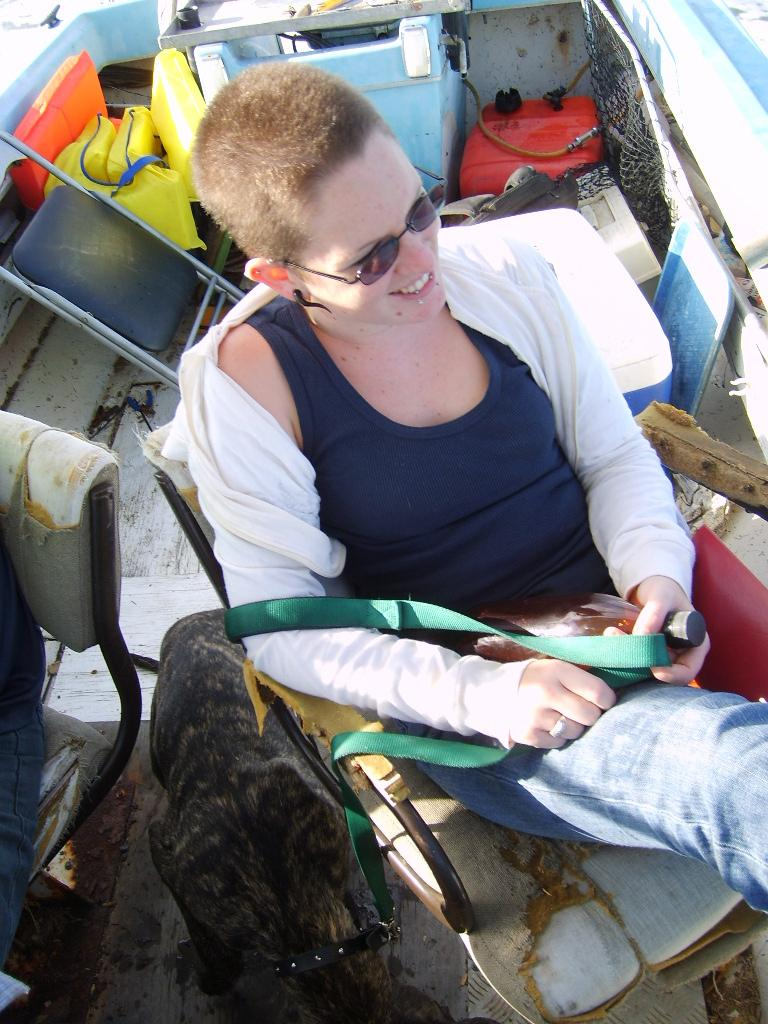Who is the main subject in the image? There is a lady in the image. What is the lady wearing on her face? The lady is wearing goggles. What object is the lady holding? The lady is holding a belt. What can be seen sitting on a chair in the image? There is a bottle sitting on a chair. What type of animal is near the lady? There is an animal near the lady. What can be seen in the background of the image? There are chairs in the background of the image. Can you describe some of the other items visible in the image? There are many other items in the image, but without specific details, it's difficult to provide a comprehensive list. What type of magic is the lady performing on the cow in the image? There is no cow present in the image, and the lady is not performing any magic. 